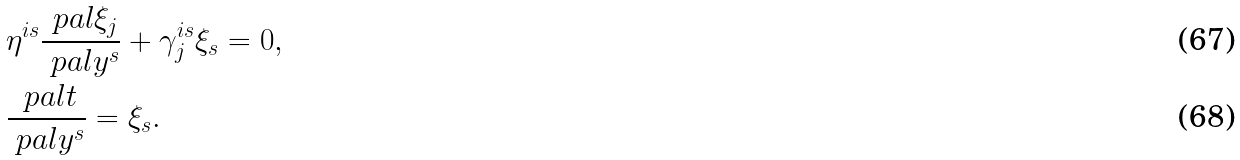Convert formula to latex. <formula><loc_0><loc_0><loc_500><loc_500>& \eta ^ { i s } \frac { \ p a l \xi _ { j } } { \ p a l y ^ { s } } + \gamma ^ { i s } _ { j } \xi _ { s } = 0 , \\ & \frac { \ p a l t } { \ p a l y ^ { s } } = \xi _ { s } .</formula> 